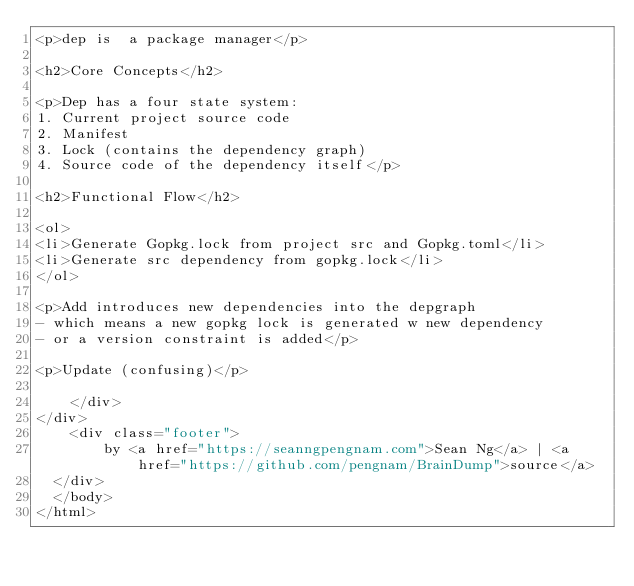Convert code to text. <code><loc_0><loc_0><loc_500><loc_500><_HTML_><p>dep is  a package manager</p>

<h2>Core Concepts</h2>

<p>Dep has a four state system:
1. Current project source code
2. Manifest
3. Lock (contains the dependency graph)
4. Source code of the dependency itself</p>

<h2>Functional Flow</h2>

<ol>
<li>Generate Gopkg.lock from project src and Gopkg.toml</li>
<li>Generate src dependency from gopkg.lock</li>
</ol>

<p>Add introduces new dependencies into the depgraph
- which means a new gopkg lock is generated w new dependency
- or a version constraint is added</p>

<p>Update (confusing)</p>

    </div>
</div>
    <div class="footer">
        by <a href="https://seanngpengnam.com">Sean Ng</a> | <a href="https://github.com/pengnam/BrainDump">source</a>
  </div>
  </body>
</html>
</code> 